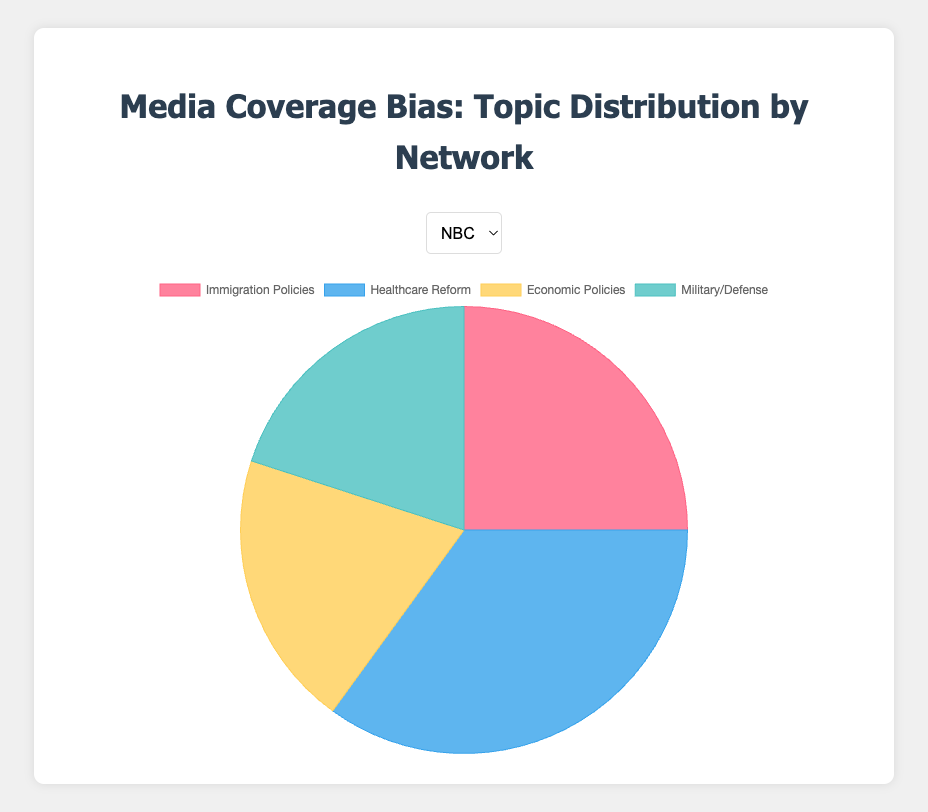Which network dedicates the most coverage to Immigration Policies? To determine which network dedicates the most coverage to Immigration Policies, we compare the percentages for this topic across the four networks. NBC dedicates 25%, CBS 30%, ABC 20%, and FOX 35%. Therefore, FOX has the highest coverage.
Answer: FOX Which topic receives the least coverage on CBS? We look at the percentages for each topic on CBS: Immigration Policies (30%), Healthcare Reform (25%), Economic Policies (25%), and Military/Defense (20%). The lowest percentage is for Military/Defense.
Answer: Military/Defense What is the total coverage percentage for Economic Policies across all networks? We add the percentages for Economic Policies from each network: NBC (20%) + CBS (25%) + ABC (25%) + FOX (25%). The total is 20 + 25 + 25 + 25 = 95%.
Answer: 95% Which network allocates the most coverage to Healthcare Reform? We look at the coverage percentages for Healthcare Reform across all networks: NBC (35%), CBS (25%), ABC (30%), and FOX (20%). NBC allocates the most coverage to this topic.
Answer: NBC Compare the total percentage coverage of Immigration Policies and Healthcare Reform for ABC. We add the percentages for Immigration Policies and Healthcare Reform on ABC: Immigration Policies (20%) + Healthcare Reform (30%) = 50%.
Answer: 50% Which network covers Military/Defense and Economic Policies equally? We examine the coverage percentages for these topics across each network. NBC has 20% for both Military/Defense and Economic Policies. No other network has equal percentages for these two topics.
Answer: NBC If we consider only NBC and CBS, which topic is covered more on average? To find the average coverage for each topic across NBC and CBS, we calculate: 
    - Immigration Policies: (25% + 30%) / 2 = 27.5%
    - Healthcare Reform: (35% + 25%) / 2 = 30%
    - Economic Policies: (20% + 25%) / 2 = 22.5%
    - Military/Defense: (20% + 20%) / 2 = 20%
Among these averages, Healthcare Reform has the highest average.
Answer: Healthcare Reform Is the combined coverage percentage for Military/Defense higher for ABC or NBC? We add the percentages for Military/Defense on both networks: ABC has 25%, and NBC has 20%. Therefore, ABC has the higher combined coverage.
Answer: ABC 